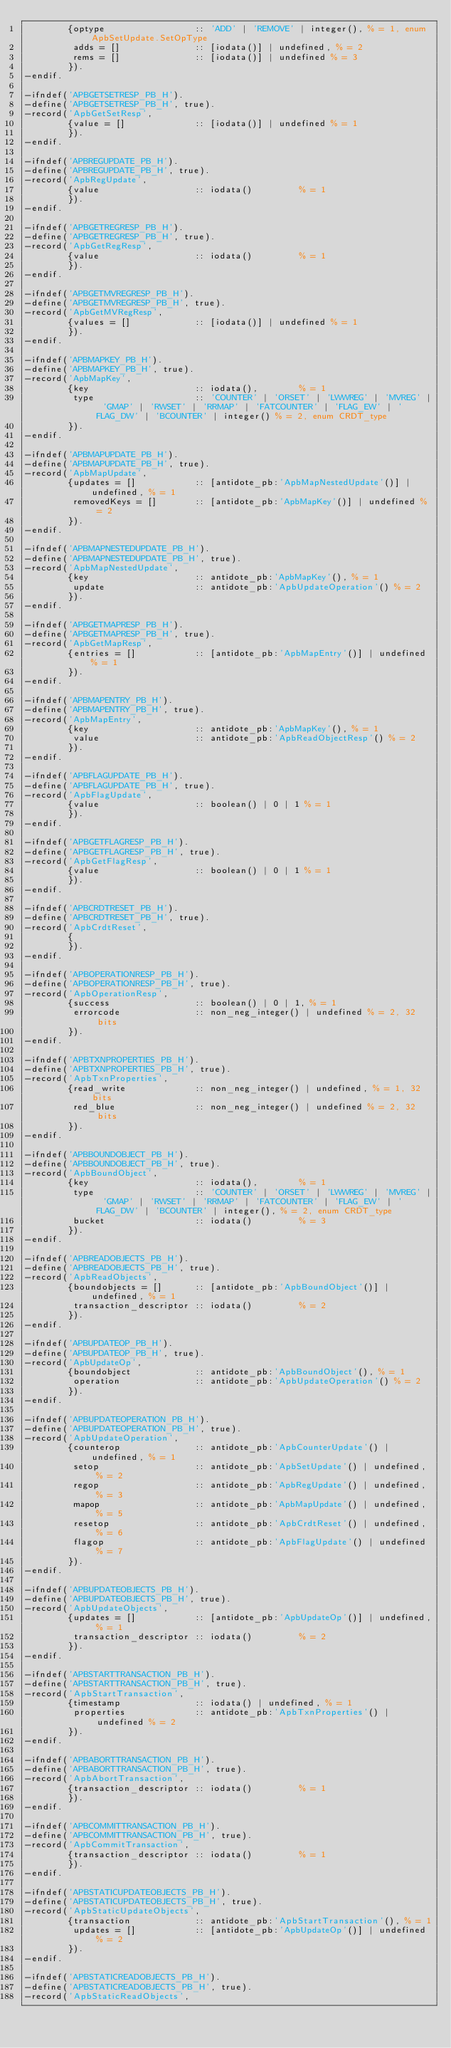Convert code to text. <code><loc_0><loc_0><loc_500><loc_500><_Erlang_>        {optype                 :: 'ADD' | 'REMOVE' | integer(), % = 1, enum ApbSetUpdate.SetOpType
         adds = []              :: [iodata()] | undefined, % = 2
         rems = []              :: [iodata()] | undefined % = 3
        }).
-endif.

-ifndef('APBGETSETRESP_PB_H').
-define('APBGETSETRESP_PB_H', true).
-record('ApbGetSetResp',
        {value = []             :: [iodata()] | undefined % = 1
        }).
-endif.

-ifndef('APBREGUPDATE_PB_H').
-define('APBREGUPDATE_PB_H', true).
-record('ApbRegUpdate',
        {value                  :: iodata()         % = 1
        }).
-endif.

-ifndef('APBGETREGRESP_PB_H').
-define('APBGETREGRESP_PB_H', true).
-record('ApbGetRegResp',
        {value                  :: iodata()         % = 1
        }).
-endif.

-ifndef('APBGETMVREGRESP_PB_H').
-define('APBGETMVREGRESP_PB_H', true).
-record('ApbGetMVRegResp',
        {values = []            :: [iodata()] | undefined % = 1
        }).
-endif.

-ifndef('APBMAPKEY_PB_H').
-define('APBMAPKEY_PB_H', true).
-record('ApbMapKey',
        {key                    :: iodata(),        % = 1
         type                   :: 'COUNTER' | 'ORSET' | 'LWWREG' | 'MVREG' | 'GMAP' | 'RWSET' | 'RRMAP' | 'FATCOUNTER' | 'FLAG_EW' | 'FLAG_DW' | 'BCOUNTER' | integer() % = 2, enum CRDT_type
        }).
-endif.

-ifndef('APBMAPUPDATE_PB_H').
-define('APBMAPUPDATE_PB_H', true).
-record('ApbMapUpdate',
        {updates = []           :: [antidote_pb:'ApbMapNestedUpdate'()] | undefined, % = 1
         removedKeys = []       :: [antidote_pb:'ApbMapKey'()] | undefined % = 2
        }).
-endif.

-ifndef('APBMAPNESTEDUPDATE_PB_H').
-define('APBMAPNESTEDUPDATE_PB_H', true).
-record('ApbMapNestedUpdate',
        {key                    :: antidote_pb:'ApbMapKey'(), % = 1
         update                 :: antidote_pb:'ApbUpdateOperation'() % = 2
        }).
-endif.

-ifndef('APBGETMAPRESP_PB_H').
-define('APBGETMAPRESP_PB_H', true).
-record('ApbGetMapResp',
        {entries = []           :: [antidote_pb:'ApbMapEntry'()] | undefined % = 1
        }).
-endif.

-ifndef('APBMAPENTRY_PB_H').
-define('APBMAPENTRY_PB_H', true).
-record('ApbMapEntry',
        {key                    :: antidote_pb:'ApbMapKey'(), % = 1
         value                  :: antidote_pb:'ApbReadObjectResp'() % = 2
        }).
-endif.

-ifndef('APBFLAGUPDATE_PB_H').
-define('APBFLAGUPDATE_PB_H', true).
-record('ApbFlagUpdate',
        {value                  :: boolean() | 0 | 1 % = 1
        }).
-endif.

-ifndef('APBGETFLAGRESP_PB_H').
-define('APBGETFLAGRESP_PB_H', true).
-record('ApbGetFlagResp',
        {value                  :: boolean() | 0 | 1 % = 1
        }).
-endif.

-ifndef('APBCRDTRESET_PB_H').
-define('APBCRDTRESET_PB_H', true).
-record('ApbCrdtReset',
        {
        }).
-endif.

-ifndef('APBOPERATIONRESP_PB_H').
-define('APBOPERATIONRESP_PB_H', true).
-record('ApbOperationResp',
        {success                :: boolean() | 0 | 1, % = 1
         errorcode              :: non_neg_integer() | undefined % = 2, 32 bits
        }).
-endif.

-ifndef('APBTXNPROPERTIES_PB_H').
-define('APBTXNPROPERTIES_PB_H', true).
-record('ApbTxnProperties',
        {read_write             :: non_neg_integer() | undefined, % = 1, 32 bits
         red_blue               :: non_neg_integer() | undefined % = 2, 32 bits
        }).
-endif.

-ifndef('APBBOUNDOBJECT_PB_H').
-define('APBBOUNDOBJECT_PB_H', true).
-record('ApbBoundObject',
        {key                    :: iodata(),        % = 1
         type                   :: 'COUNTER' | 'ORSET' | 'LWWREG' | 'MVREG' | 'GMAP' | 'RWSET' | 'RRMAP' | 'FATCOUNTER' | 'FLAG_EW' | 'FLAG_DW' | 'BCOUNTER' | integer(), % = 2, enum CRDT_type
         bucket                 :: iodata()         % = 3
        }).
-endif.

-ifndef('APBREADOBJECTS_PB_H').
-define('APBREADOBJECTS_PB_H', true).
-record('ApbReadObjects',
        {boundobjects = []      :: [antidote_pb:'ApbBoundObject'()] | undefined, % = 1
         transaction_descriptor :: iodata()         % = 2
        }).
-endif.

-ifndef('APBUPDATEOP_PB_H').
-define('APBUPDATEOP_PB_H', true).
-record('ApbUpdateOp',
        {boundobject            :: antidote_pb:'ApbBoundObject'(), % = 1
         operation              :: antidote_pb:'ApbUpdateOperation'() % = 2
        }).
-endif.

-ifndef('APBUPDATEOPERATION_PB_H').
-define('APBUPDATEOPERATION_PB_H', true).
-record('ApbUpdateOperation',
        {counterop              :: antidote_pb:'ApbCounterUpdate'() | undefined, % = 1
         setop                  :: antidote_pb:'ApbSetUpdate'() | undefined, % = 2
         regop                  :: antidote_pb:'ApbRegUpdate'() | undefined, % = 3
         mapop                  :: antidote_pb:'ApbMapUpdate'() | undefined, % = 5
         resetop                :: antidote_pb:'ApbCrdtReset'() | undefined, % = 6
         flagop                 :: antidote_pb:'ApbFlagUpdate'() | undefined % = 7
        }).
-endif.

-ifndef('APBUPDATEOBJECTS_PB_H').
-define('APBUPDATEOBJECTS_PB_H', true).
-record('ApbUpdateObjects',
        {updates = []           :: [antidote_pb:'ApbUpdateOp'()] | undefined, % = 1
         transaction_descriptor :: iodata()         % = 2
        }).
-endif.

-ifndef('APBSTARTTRANSACTION_PB_H').
-define('APBSTARTTRANSACTION_PB_H', true).
-record('ApbStartTransaction',
        {timestamp              :: iodata() | undefined, % = 1
         properties             :: antidote_pb:'ApbTxnProperties'() | undefined % = 2
        }).
-endif.

-ifndef('APBABORTTRANSACTION_PB_H').
-define('APBABORTTRANSACTION_PB_H', true).
-record('ApbAbortTransaction',
        {transaction_descriptor :: iodata()         % = 1
        }).
-endif.

-ifndef('APBCOMMITTRANSACTION_PB_H').
-define('APBCOMMITTRANSACTION_PB_H', true).
-record('ApbCommitTransaction',
        {transaction_descriptor :: iodata()         % = 1
        }).
-endif.

-ifndef('APBSTATICUPDATEOBJECTS_PB_H').
-define('APBSTATICUPDATEOBJECTS_PB_H', true).
-record('ApbStaticUpdateObjects',
        {transaction            :: antidote_pb:'ApbStartTransaction'(), % = 1
         updates = []           :: [antidote_pb:'ApbUpdateOp'()] | undefined % = 2
        }).
-endif.

-ifndef('APBSTATICREADOBJECTS_PB_H').
-define('APBSTATICREADOBJECTS_PB_H', true).
-record('ApbStaticReadObjects',</code> 